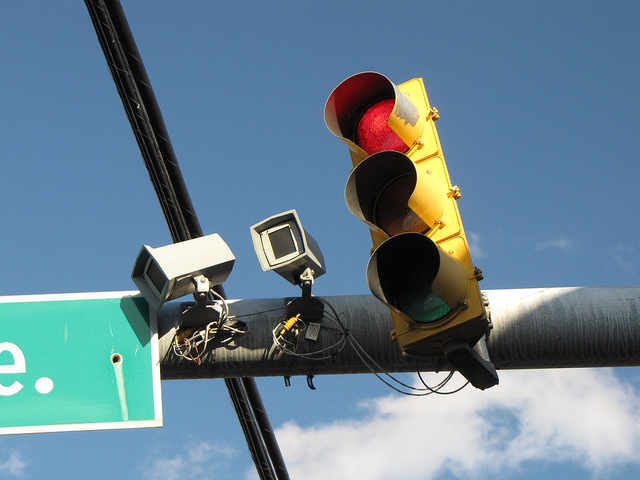Are there any signs or symbols visible, and if so, what do they indicate? There is a street sign visible displaying 'State St.' which indicates the name of the street. The traffic signal itself conveys the standard traffic control instructions with the red light signaling drivers to stop. 